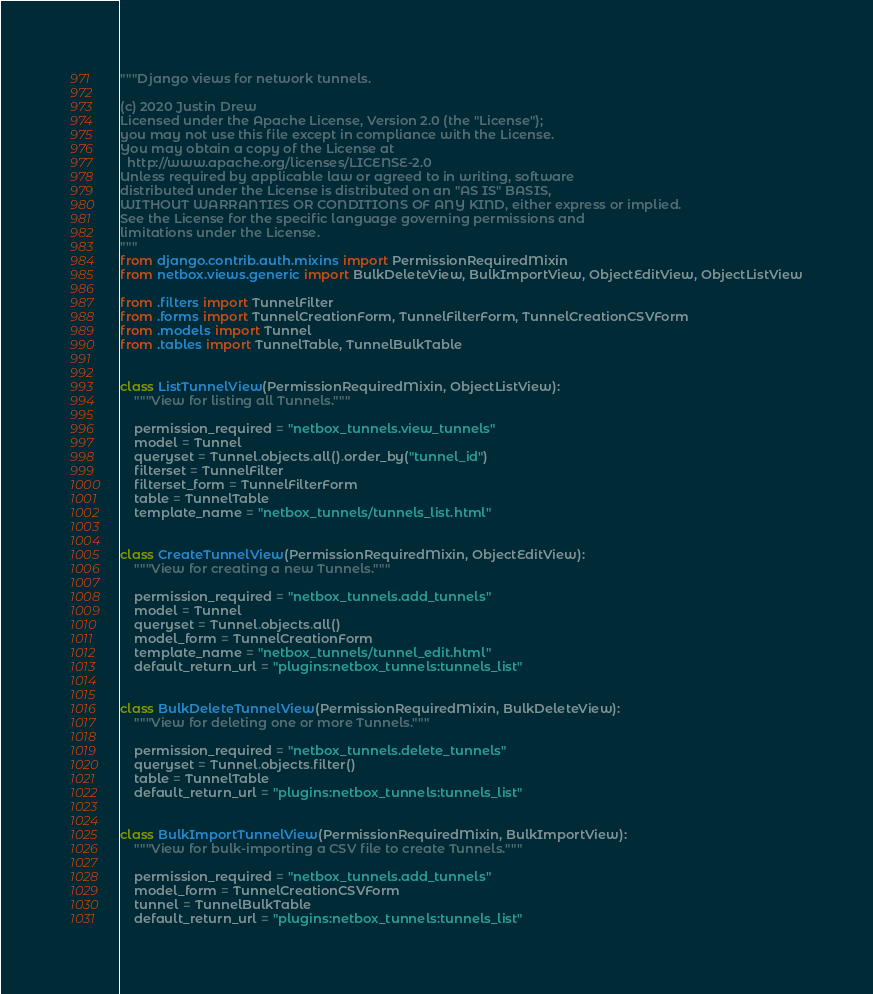<code> <loc_0><loc_0><loc_500><loc_500><_Python_>"""Django views for network tunnels.

(c) 2020 Justin Drew
Licensed under the Apache License, Version 2.0 (the "License");
you may not use this file except in compliance with the License.
You may obtain a copy of the License at
  http://www.apache.org/licenses/LICENSE-2.0
Unless required by applicable law or agreed to in writing, software
distributed under the License is distributed on an "AS IS" BASIS,
WITHOUT WARRANTIES OR CONDITIONS OF ANY KIND, either express or implied.
See the License for the specific language governing permissions and
limitations under the License.
"""
from django.contrib.auth.mixins import PermissionRequiredMixin
from netbox.views.generic import BulkDeleteView, BulkImportView, ObjectEditView, ObjectListView

from .filters import TunnelFilter
from .forms import TunnelCreationForm, TunnelFilterForm, TunnelCreationCSVForm
from .models import Tunnel
from .tables import TunnelTable, TunnelBulkTable


class ListTunnelView(PermissionRequiredMixin, ObjectListView):
    """View for listing all Tunnels."""

    permission_required = "netbox_tunnels.view_tunnels"
    model = Tunnel
    queryset = Tunnel.objects.all().order_by("tunnel_id")
    filterset = TunnelFilter
    filterset_form = TunnelFilterForm
    table = TunnelTable
    template_name = "netbox_tunnels/tunnels_list.html"


class CreateTunnelView(PermissionRequiredMixin, ObjectEditView):
    """View for creating a new Tunnels."""

    permission_required = "netbox_tunnels.add_tunnels"
    model = Tunnel
    queryset = Tunnel.objects.all()
    model_form = TunnelCreationForm
    template_name = "netbox_tunnels/tunnel_edit.html"
    default_return_url = "plugins:netbox_tunnels:tunnels_list"


class BulkDeleteTunnelView(PermissionRequiredMixin, BulkDeleteView):
    """View for deleting one or more Tunnels."""

    permission_required = "netbox_tunnels.delete_tunnels"
    queryset = Tunnel.objects.filter()
    table = TunnelTable
    default_return_url = "plugins:netbox_tunnels:tunnels_list"


class BulkImportTunnelView(PermissionRequiredMixin, BulkImportView):
    """View for bulk-importing a CSV file to create Tunnels."""

    permission_required = "netbox_tunnels.add_tunnels"
    model_form = TunnelCreationCSVForm
    tunnel = TunnelBulkTable
    default_return_url = "plugins:netbox_tunnels:tunnels_list"
</code> 